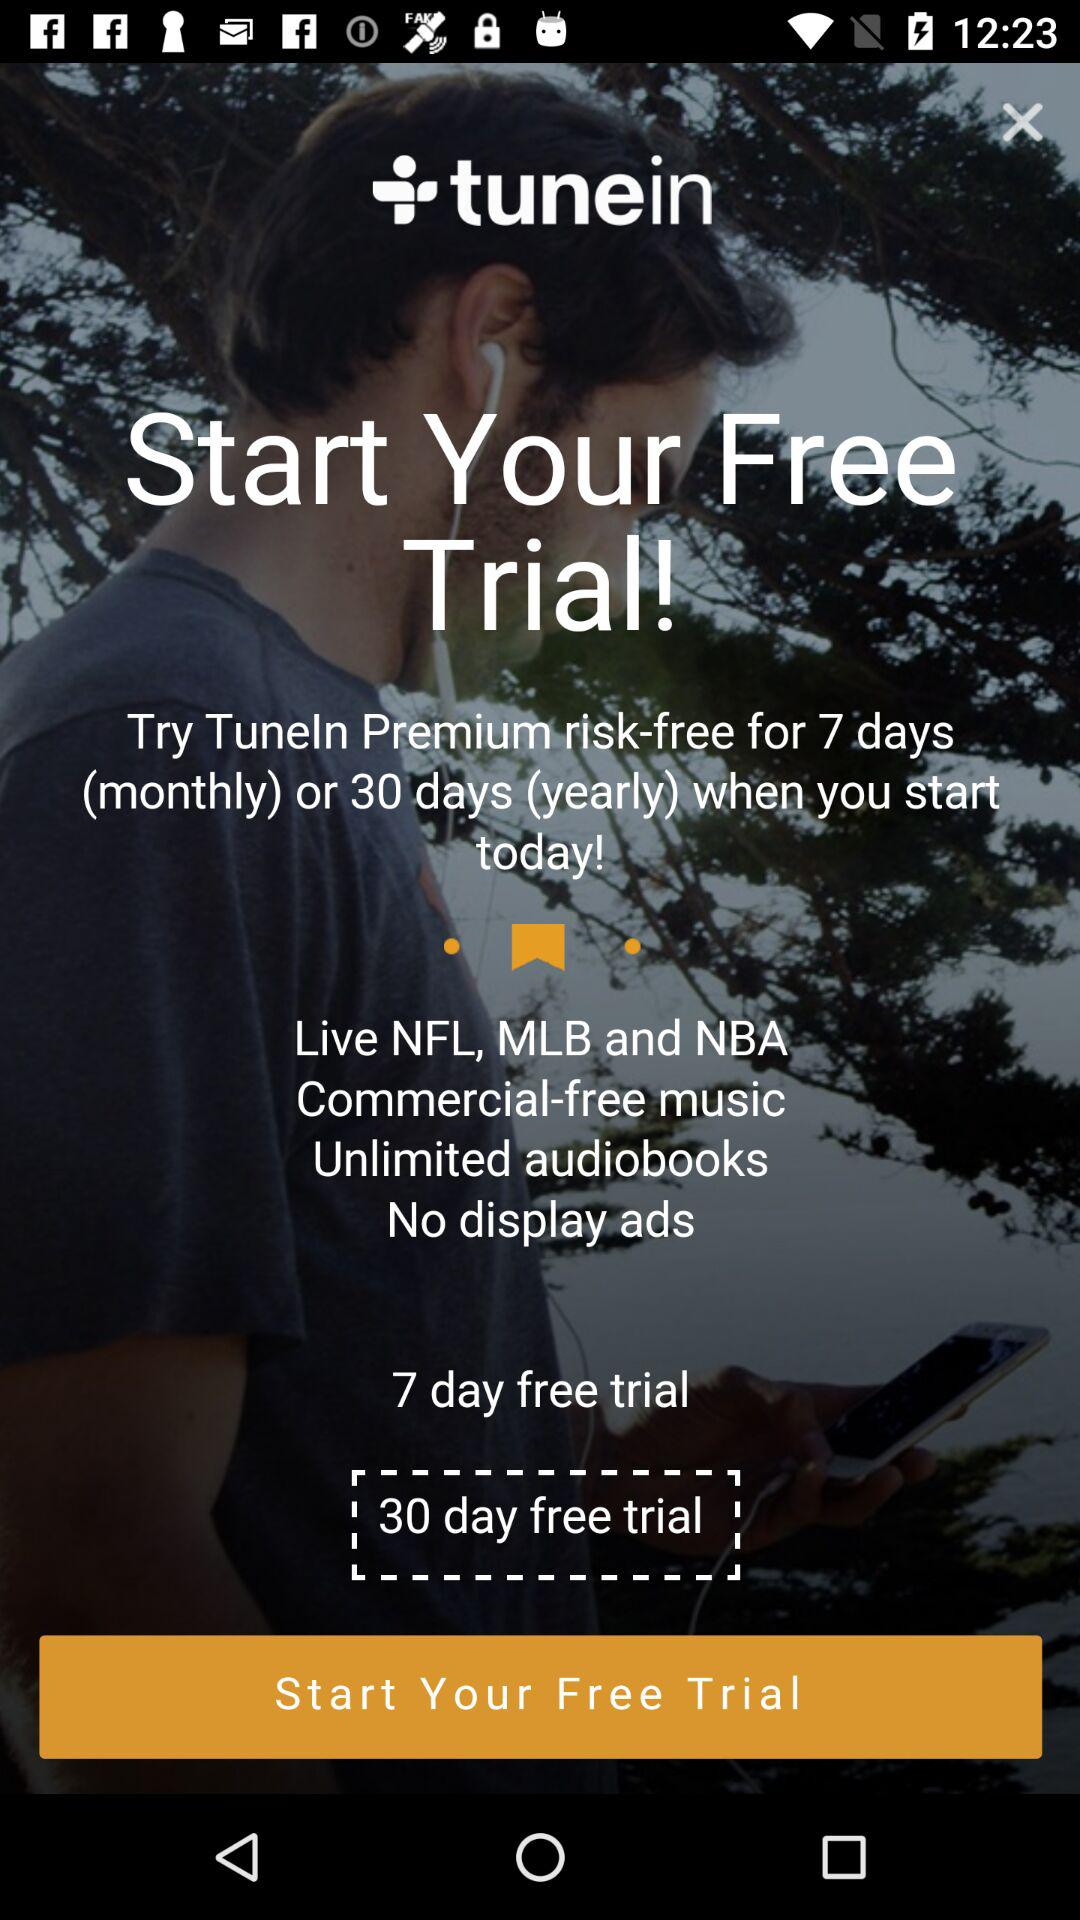For how many days is there a free trial? A free trial is for 7 days and 30 days. 